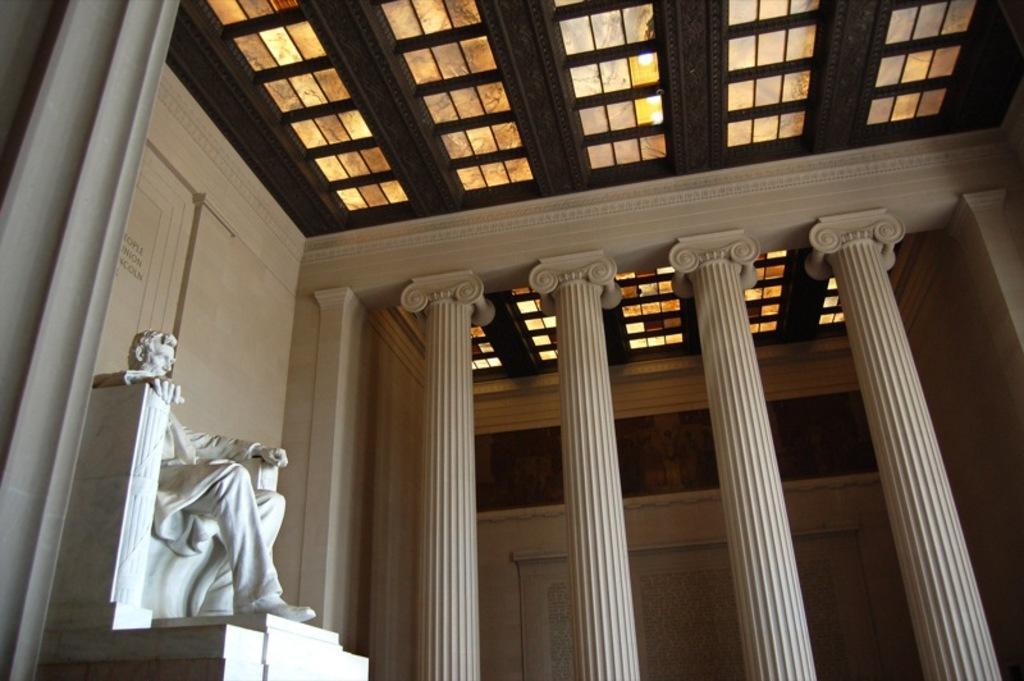In one or two sentences, can you explain what this image depicts? I think this picture was taken inside the building. These are the pillars. This is the sculpture of the man. I think this is the ceiling, which is at the top. 